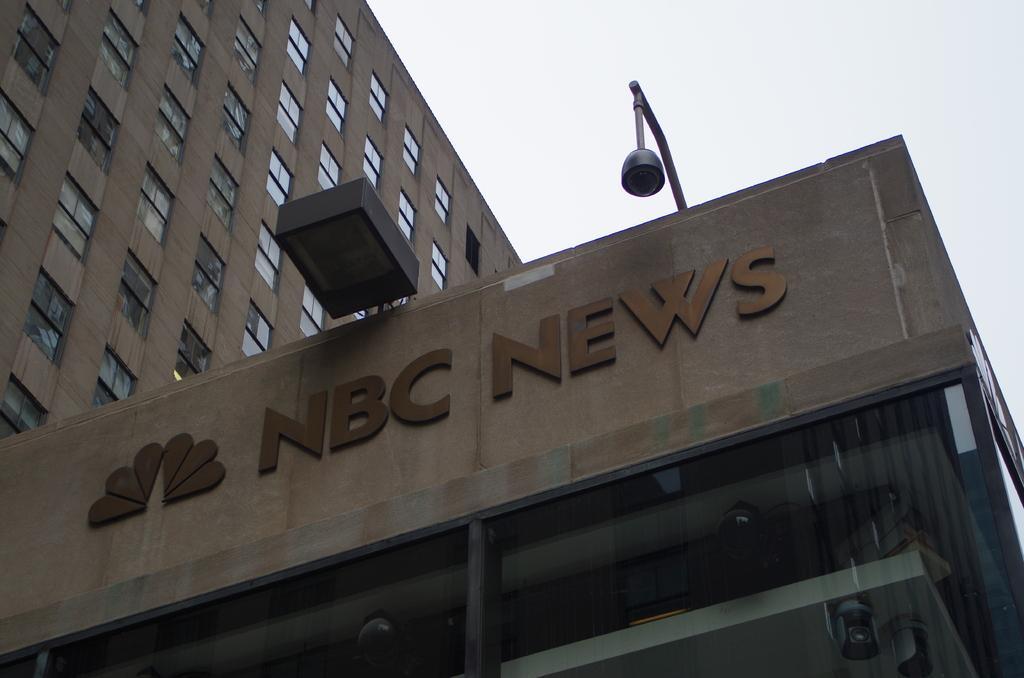In one or two sentences, can you explain what this image depicts? In this image we can see a building with windows. Also we can see a camera with a pole. And there is a name and emblem on the building. In the background there is sky. 